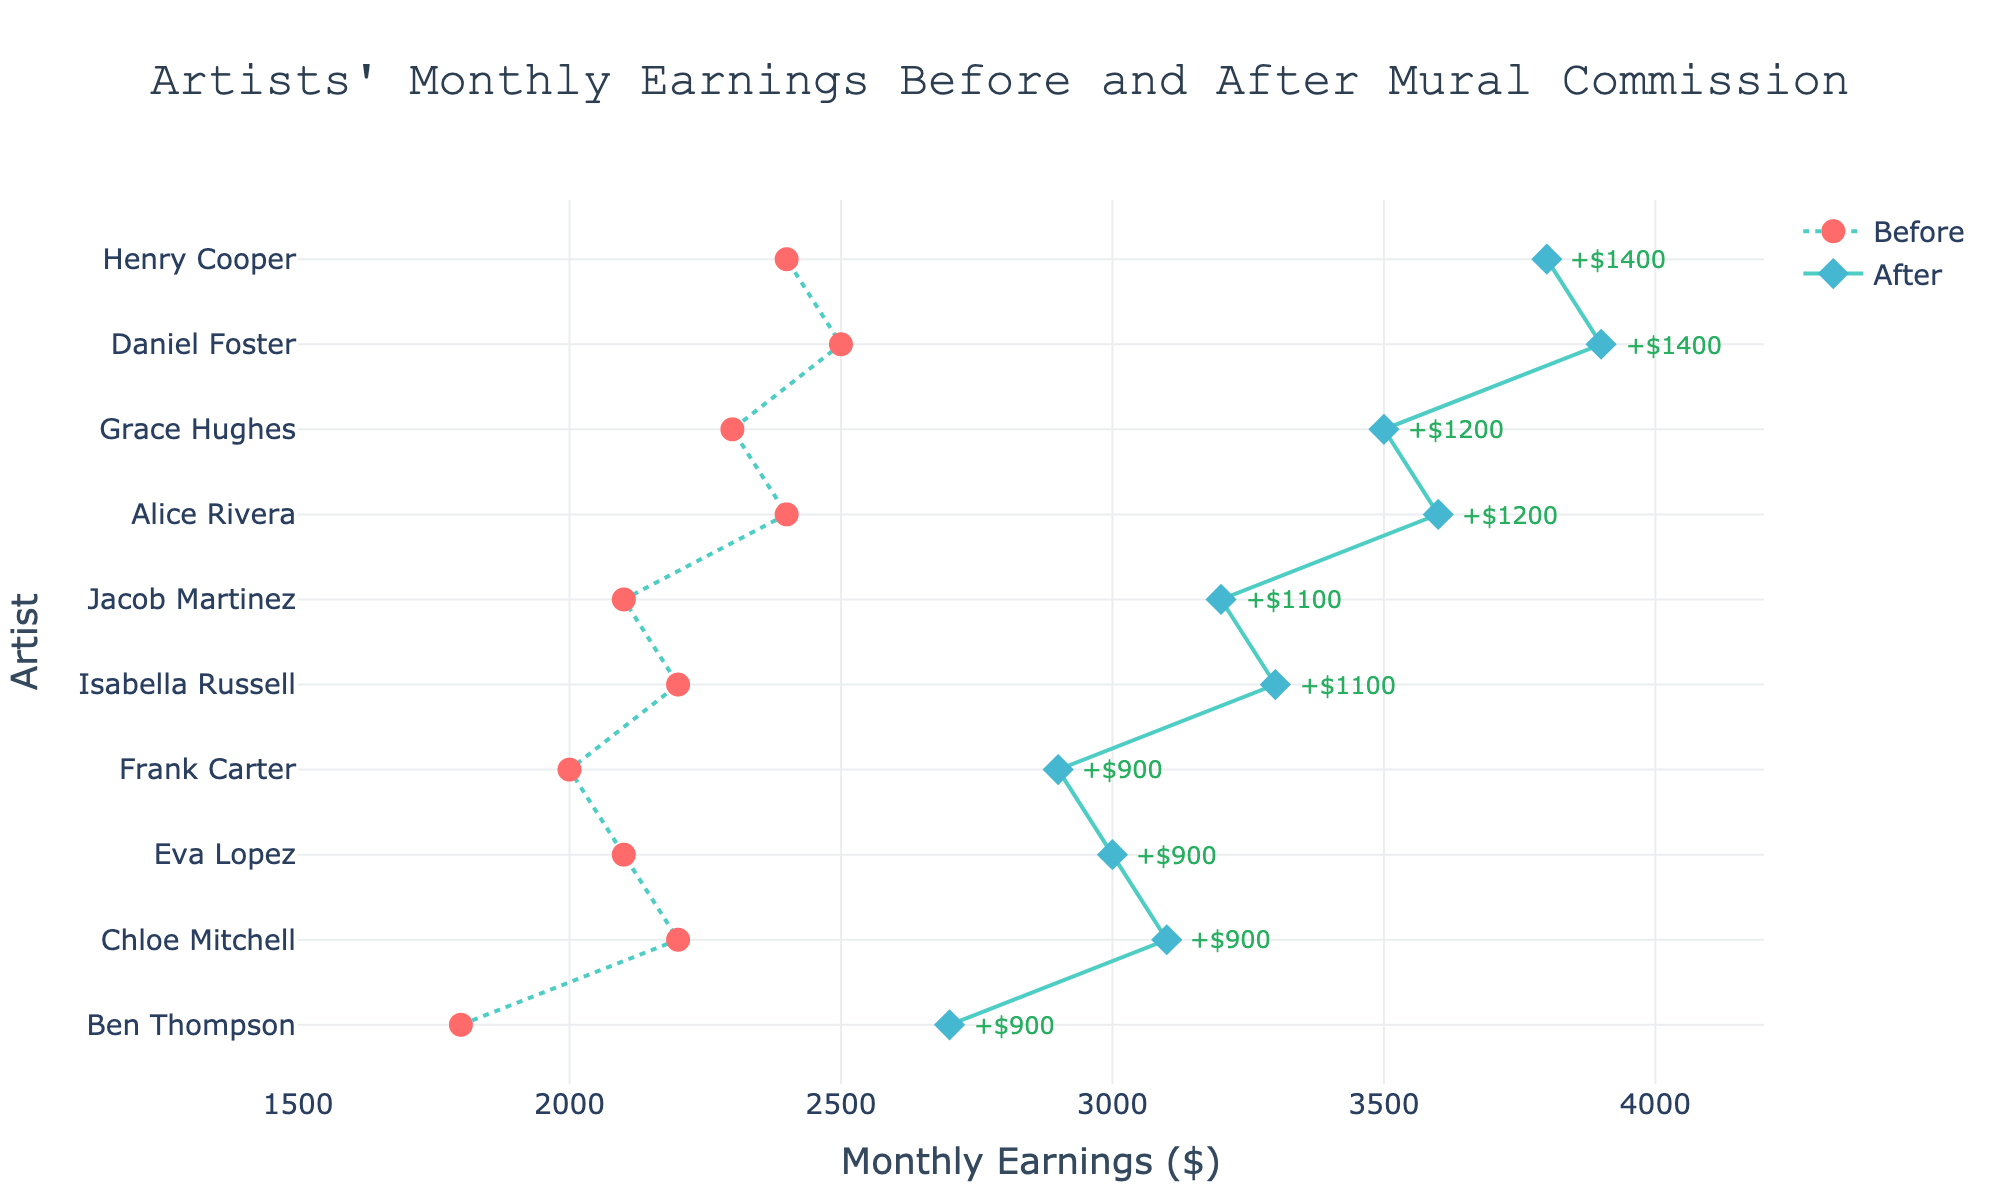what's the title of the figure? The title is placed at the top of the figure and usually summarizes what the figure shows.
Answer: Artists' Monthly Earnings Before and After Mural Commission what's the range of the x-axis? The x-axis represents monthly earnings and the tick marks along this axis show the range. The range starts at $1500 and ends at $4200.
Answer: 1500 to 4200 how many artists are shown in the figure? Each artist's name is listed on the y-axis and the lines with markers represent their data points. By counting the number of names on the y-axis, we find there are 10 artists.
Answer: 10 which artist had the highest monthly earnings after commissioning a mural? By checking the values for "Monthly Earnings After ($)" on the x-axis and finding the highest point, we see that Daniel Foster has the highest value at $3900.
Answer: Daniel Foster which artist had the smallest increase in earnings after commissioning a mural? The increase in earnings is labeled next to each artist. The smallest increase shown is $900, corresponding to Ben Thompson.
Answer: Ben Thompson what's the average monthly earnings before commissioning a mural? Summing up all "Monthly Earnings Before" values ($2400, $1800, $2200, $2500, $2100, $2000, $2300, $2400, $2200, $2100) equals $22000. Dividing by the number of data points (10) gives an average of $2200.
Answer: 2200 which artist had the greatest increase in earnings, and by how much? By reviewing the green annotations, Daniel Foster shows the greatest increase, which is $1400.
Answer: Daniel Foster, $1400 compare the monthly earnings before and after for Chloe Mitchell. What's the difference? Chloe Mitchell's earnings before are $2200 and after are $3100. The difference is calculated as $3100 - $2200 = $900.
Answer: $900 what color represents the monthly earnings after commissioning a mural in the plot? The markers for "Monthly Earnings After" are diamond-shaped and colored in a shade of blue.
Answer: Blue what is the total monthly earnings after commissioning murals for all artists combined? Summing up all "Monthly Earnings After" values ($3600, $2700, $3100, $3900, $3000, $2900, $3500, $3800, $3300, $3200) equals $33000.
Answer: 33000 